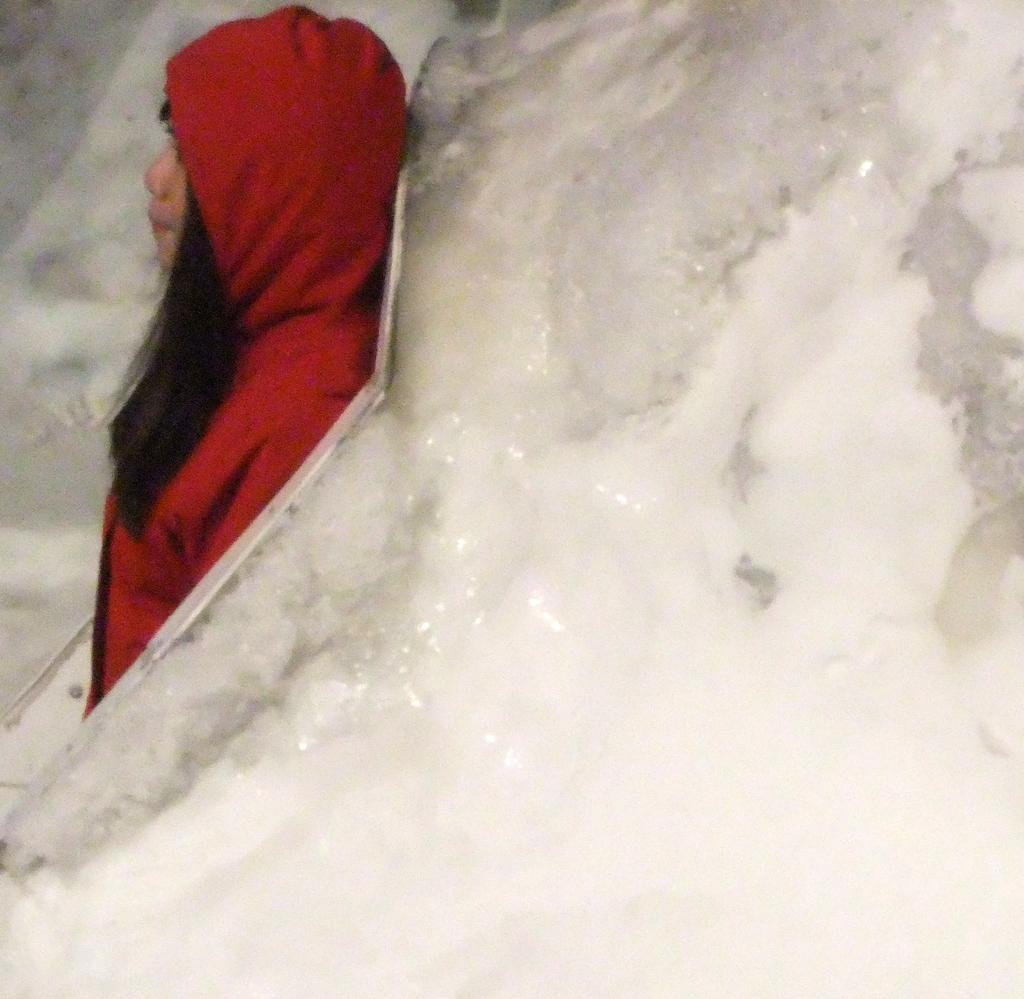What is the main subject of the image? There is a person standing in the image. What is the weather or environment like in the image? There is snow visible in the image. What type of knot can be seen tied around the person's neck in the image? There is no knot visible around the person's neck in the image. Is there a circle drawn in the snow in the image? There is no circle drawn in the snow in the image. 